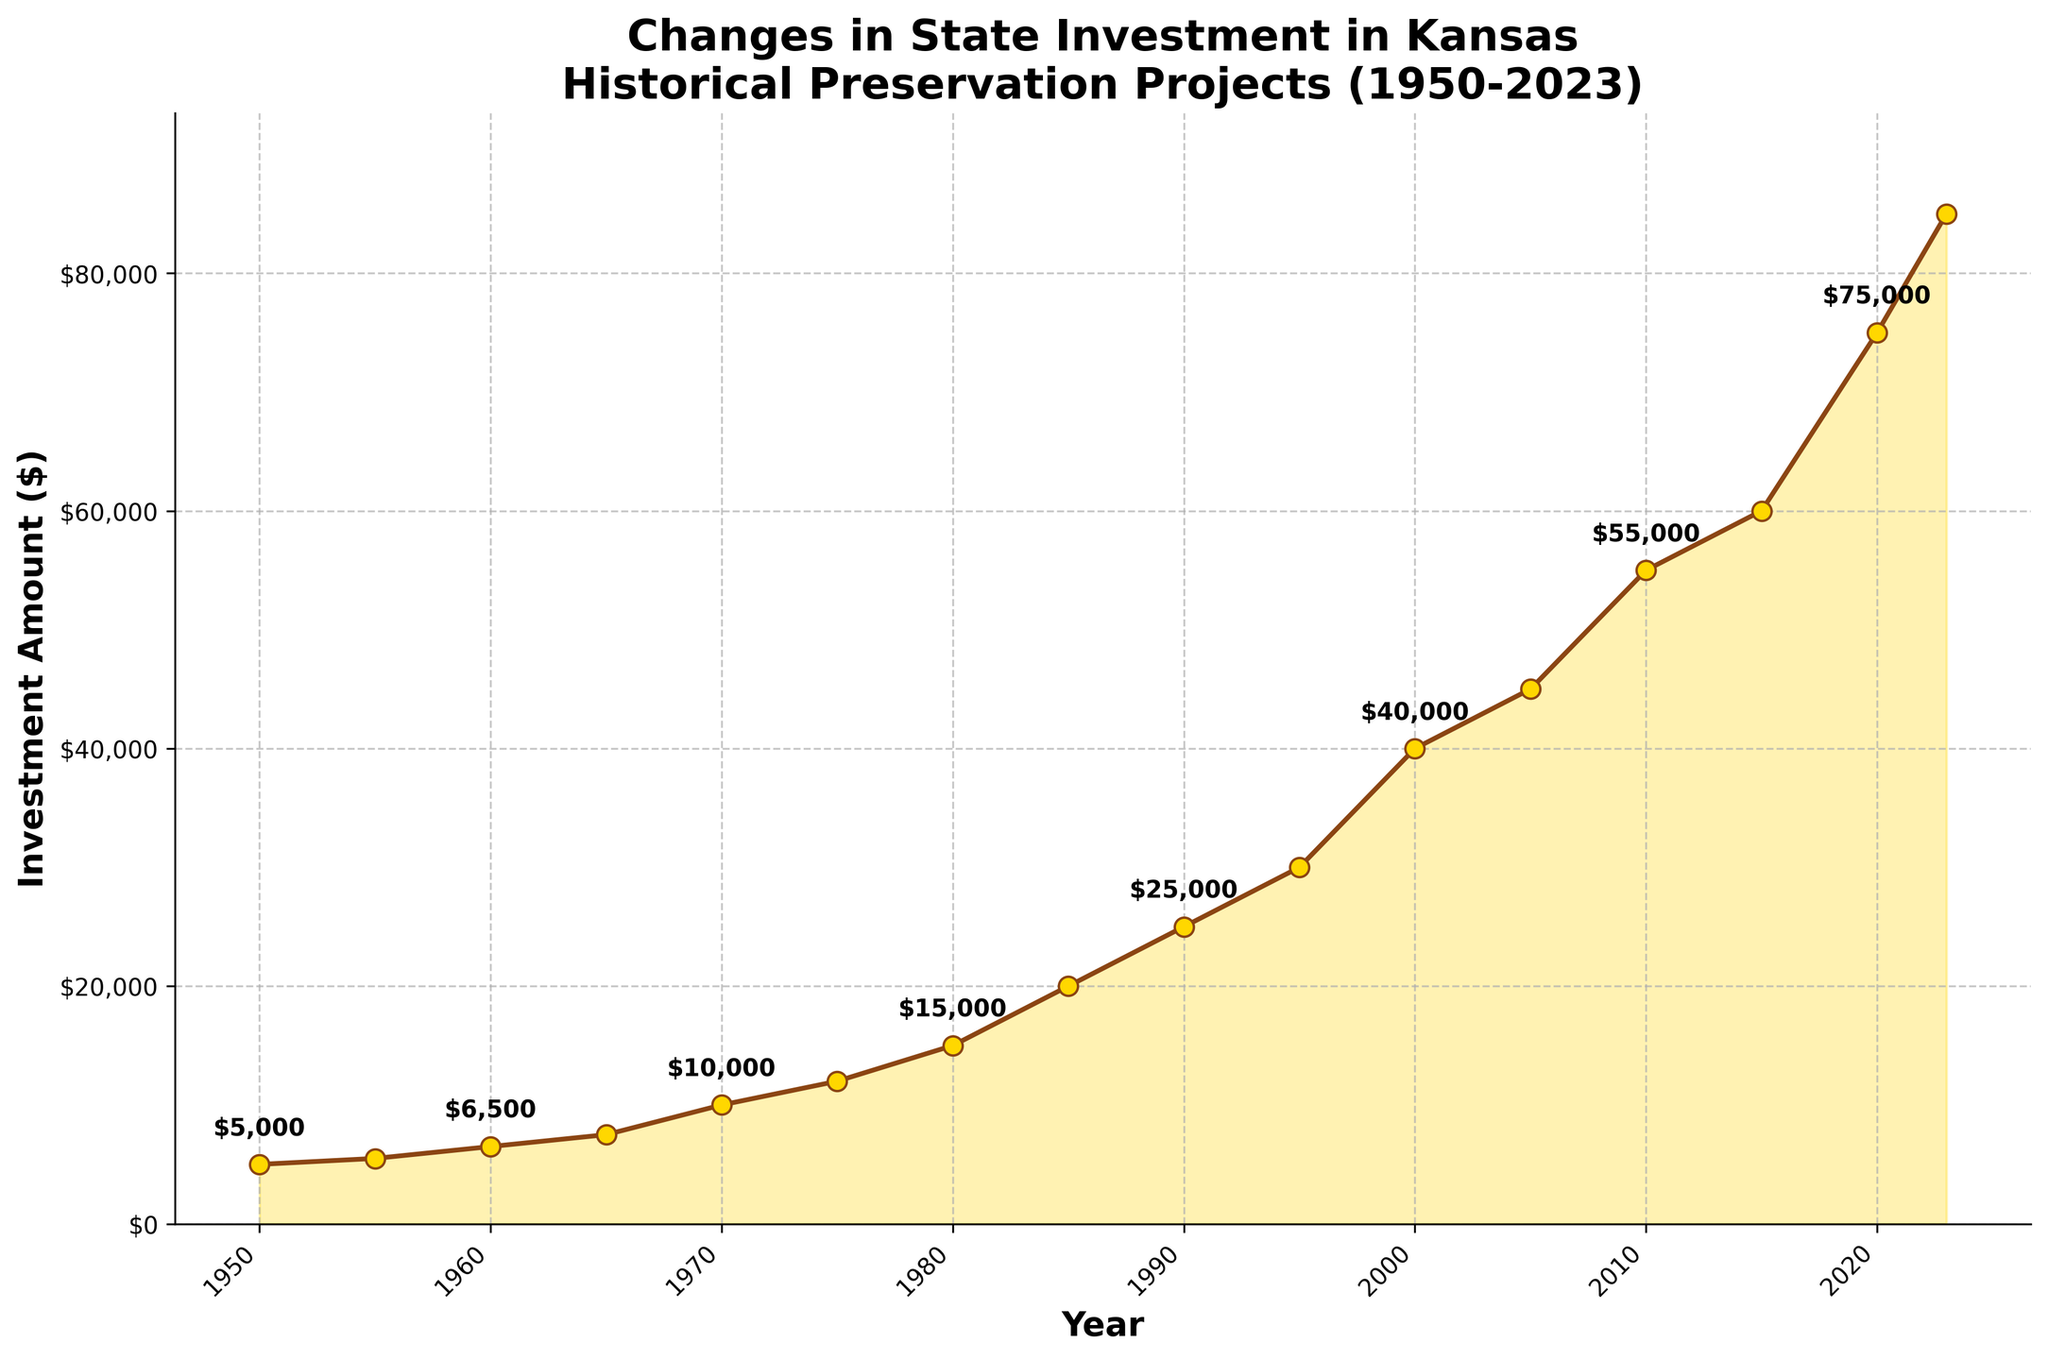What is the title of the plot? The title of the plot is usually prominently displayed at the top of the figure. In this case, the title provides an overview of what the plot represents. It reads, "Changes in State Investment in Kansas Historical Preservation Projects (1950-2023)."
Answer: Changes in State Investment in Kansas Historical Preservation Projects (1950-2023) Which year marks the highest investment amount? To find the highest investment amount, look for the peak on the plot where the investment amount reaches its maximum. Here, the highest point is in 2023, with an investment of $85,000.
Answer: 2023 What was the amount invested in 1970? Read the point on the line corresponding to the year 1970. The label at this point or the y-axis value will indicate the investment amount. For 1970, it is $10,000.
Answer: $10,000 By how much did the investment amount increase from 1950 to 1980? Find the investment amounts for the years 1950 and 1980 and subtract the 1950 amount from the 1980 amount. Specifically, $15,000 (1980) - $5,000 (1950) = $10,000.
Answer: $10,000 What is the average investment from 2000 to 2023? Sum the investment amounts for each of the years from 2000 to 2023 and divide by the number of data points in that range. The investment amounts are $40,000, $45,000, $55,000, $60,000, $75,000, $85,000. Therefore, (40,000 + 45,000 + 55,000 + 60,000 + 75,000 + 85,000) / 6 = $60,000.
Answer: $60,000 Which periods (in years) have the longest span with no increase in investment? Look for flat parts of the plot where the line doesn't move upwards, indicating periods with no increase. The most prolonged periods without an increase appear to be from 1950 to 1955 (5 years) and 1955 to 1960 (5 years).
Answer: 1950-1955, 1955-1960 (5 years each) What is the difference in investment between 1990 and 2000? Identify the investment amounts for 1990 and 2000 from the plot, then subtract the former from the latter. Here, $40,000 (2000) - $25,000 (1990) = $15,000.
Answer: $15,000 How much did the investment amount increase from 2010 to 2020? Check the values for 2010 and 2020, then subtract the 2010 value from the 2020 value. Specifically, $75,000 (2020) - $55,000 (2010) = $20,000.
Answer: $20,000 Was there any year between 1950 and 2023 when the investment decreased compared to the previous year? To answer this, verify if the plot line ever dips downward. In this plot, the line consistently rises, indicating there was no year when the investment decreased compared to the previous year.
Answer: No 